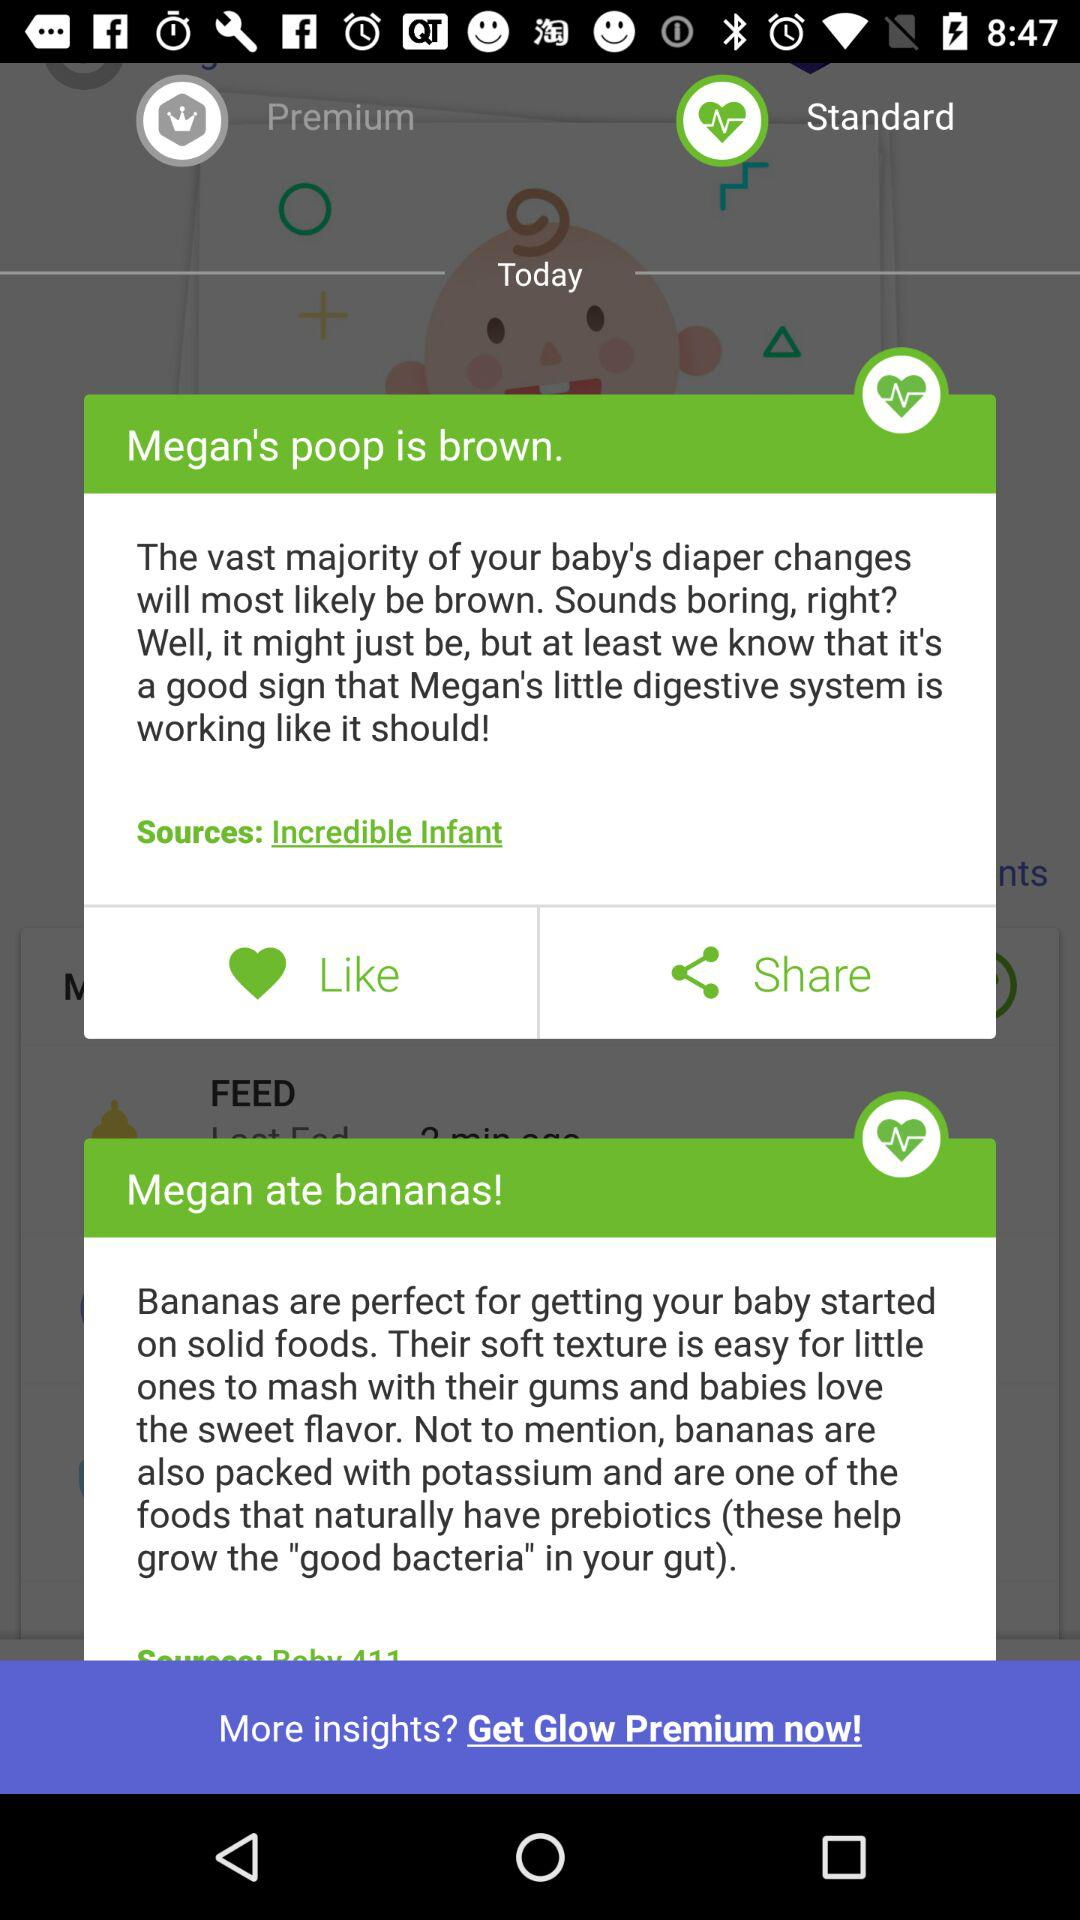What food is a rich source of potassium? A rich source of potassium is bananas. 